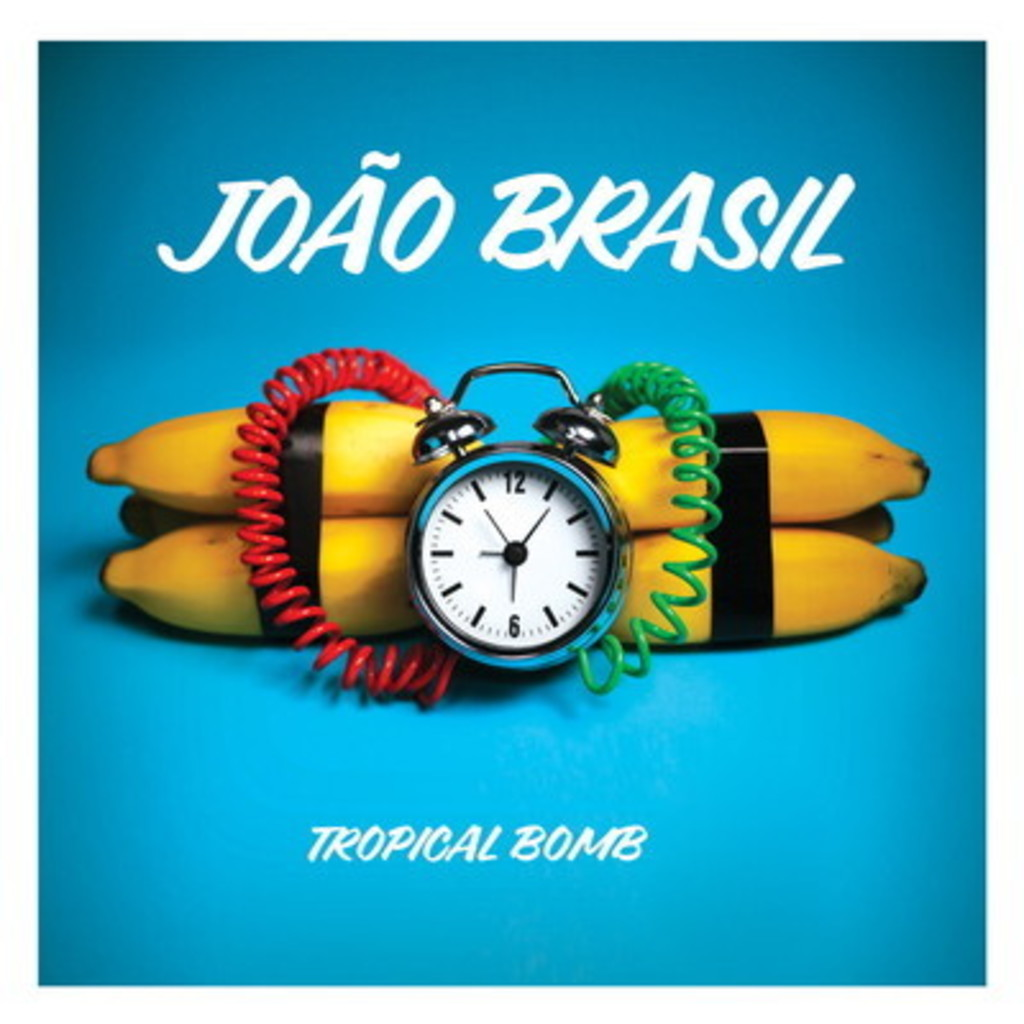What do you think is going on in this snapshot? The image appears to be a creative and colorful album cover for João Brasil's 'Tropical Bomb'. The backdrop is a vibrant blue, highlighting a cluster of yellow bananas tied together with multi-colored telephone cords in red and green. Resting atop the bananas is a classic alarm clock pointing to six o'clock, possibly symbolizing a specific time or event related to the album's theme. The artist's name 'JOÃO BRASIL' and the album title 'TROPICAL BOMB' are prominently displayed in a playful, bold typeface, enhancing the overall funky and whimsical vibe of the cover. 